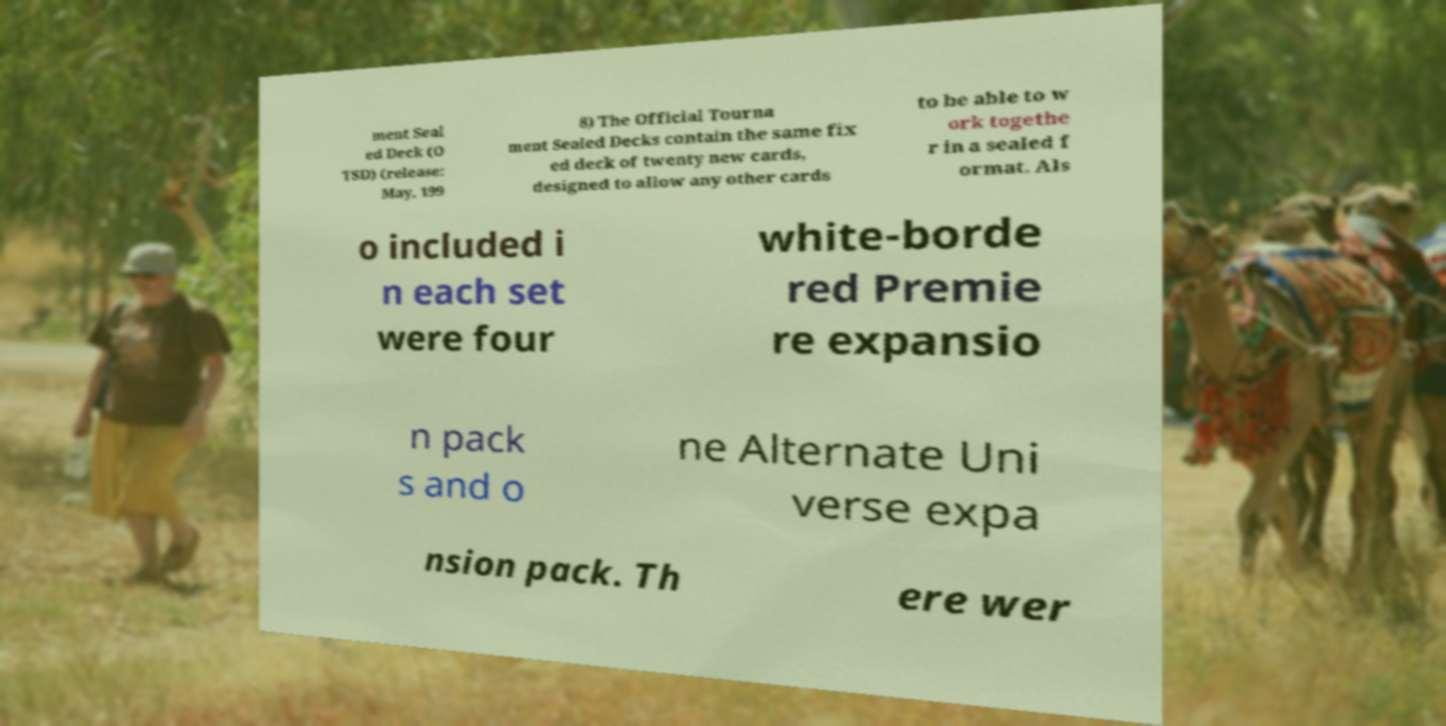I need the written content from this picture converted into text. Can you do that? ment Seal ed Deck (O TSD) (release: May, 199 8) The Official Tourna ment Sealed Decks contain the same fix ed deck of twenty new cards, designed to allow any other cards to be able to w ork togethe r in a sealed f ormat. Als o included i n each set were four white-borde red Premie re expansio n pack s and o ne Alternate Uni verse expa nsion pack. Th ere wer 